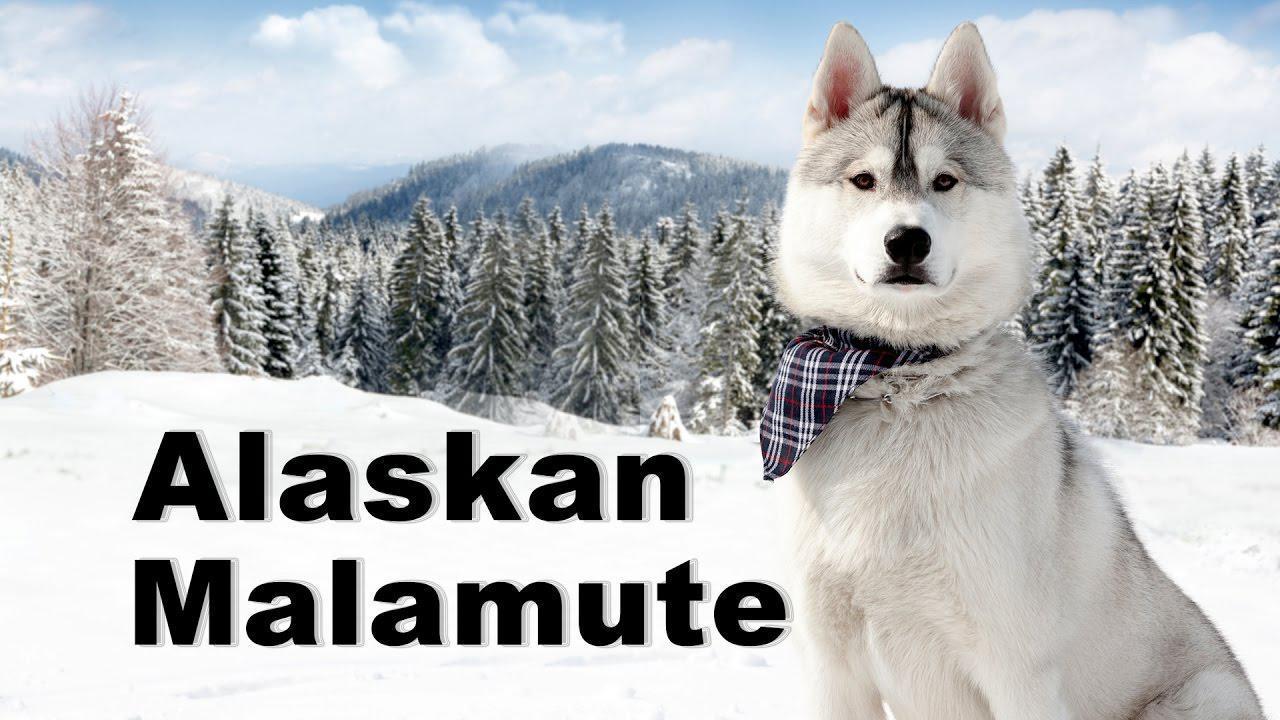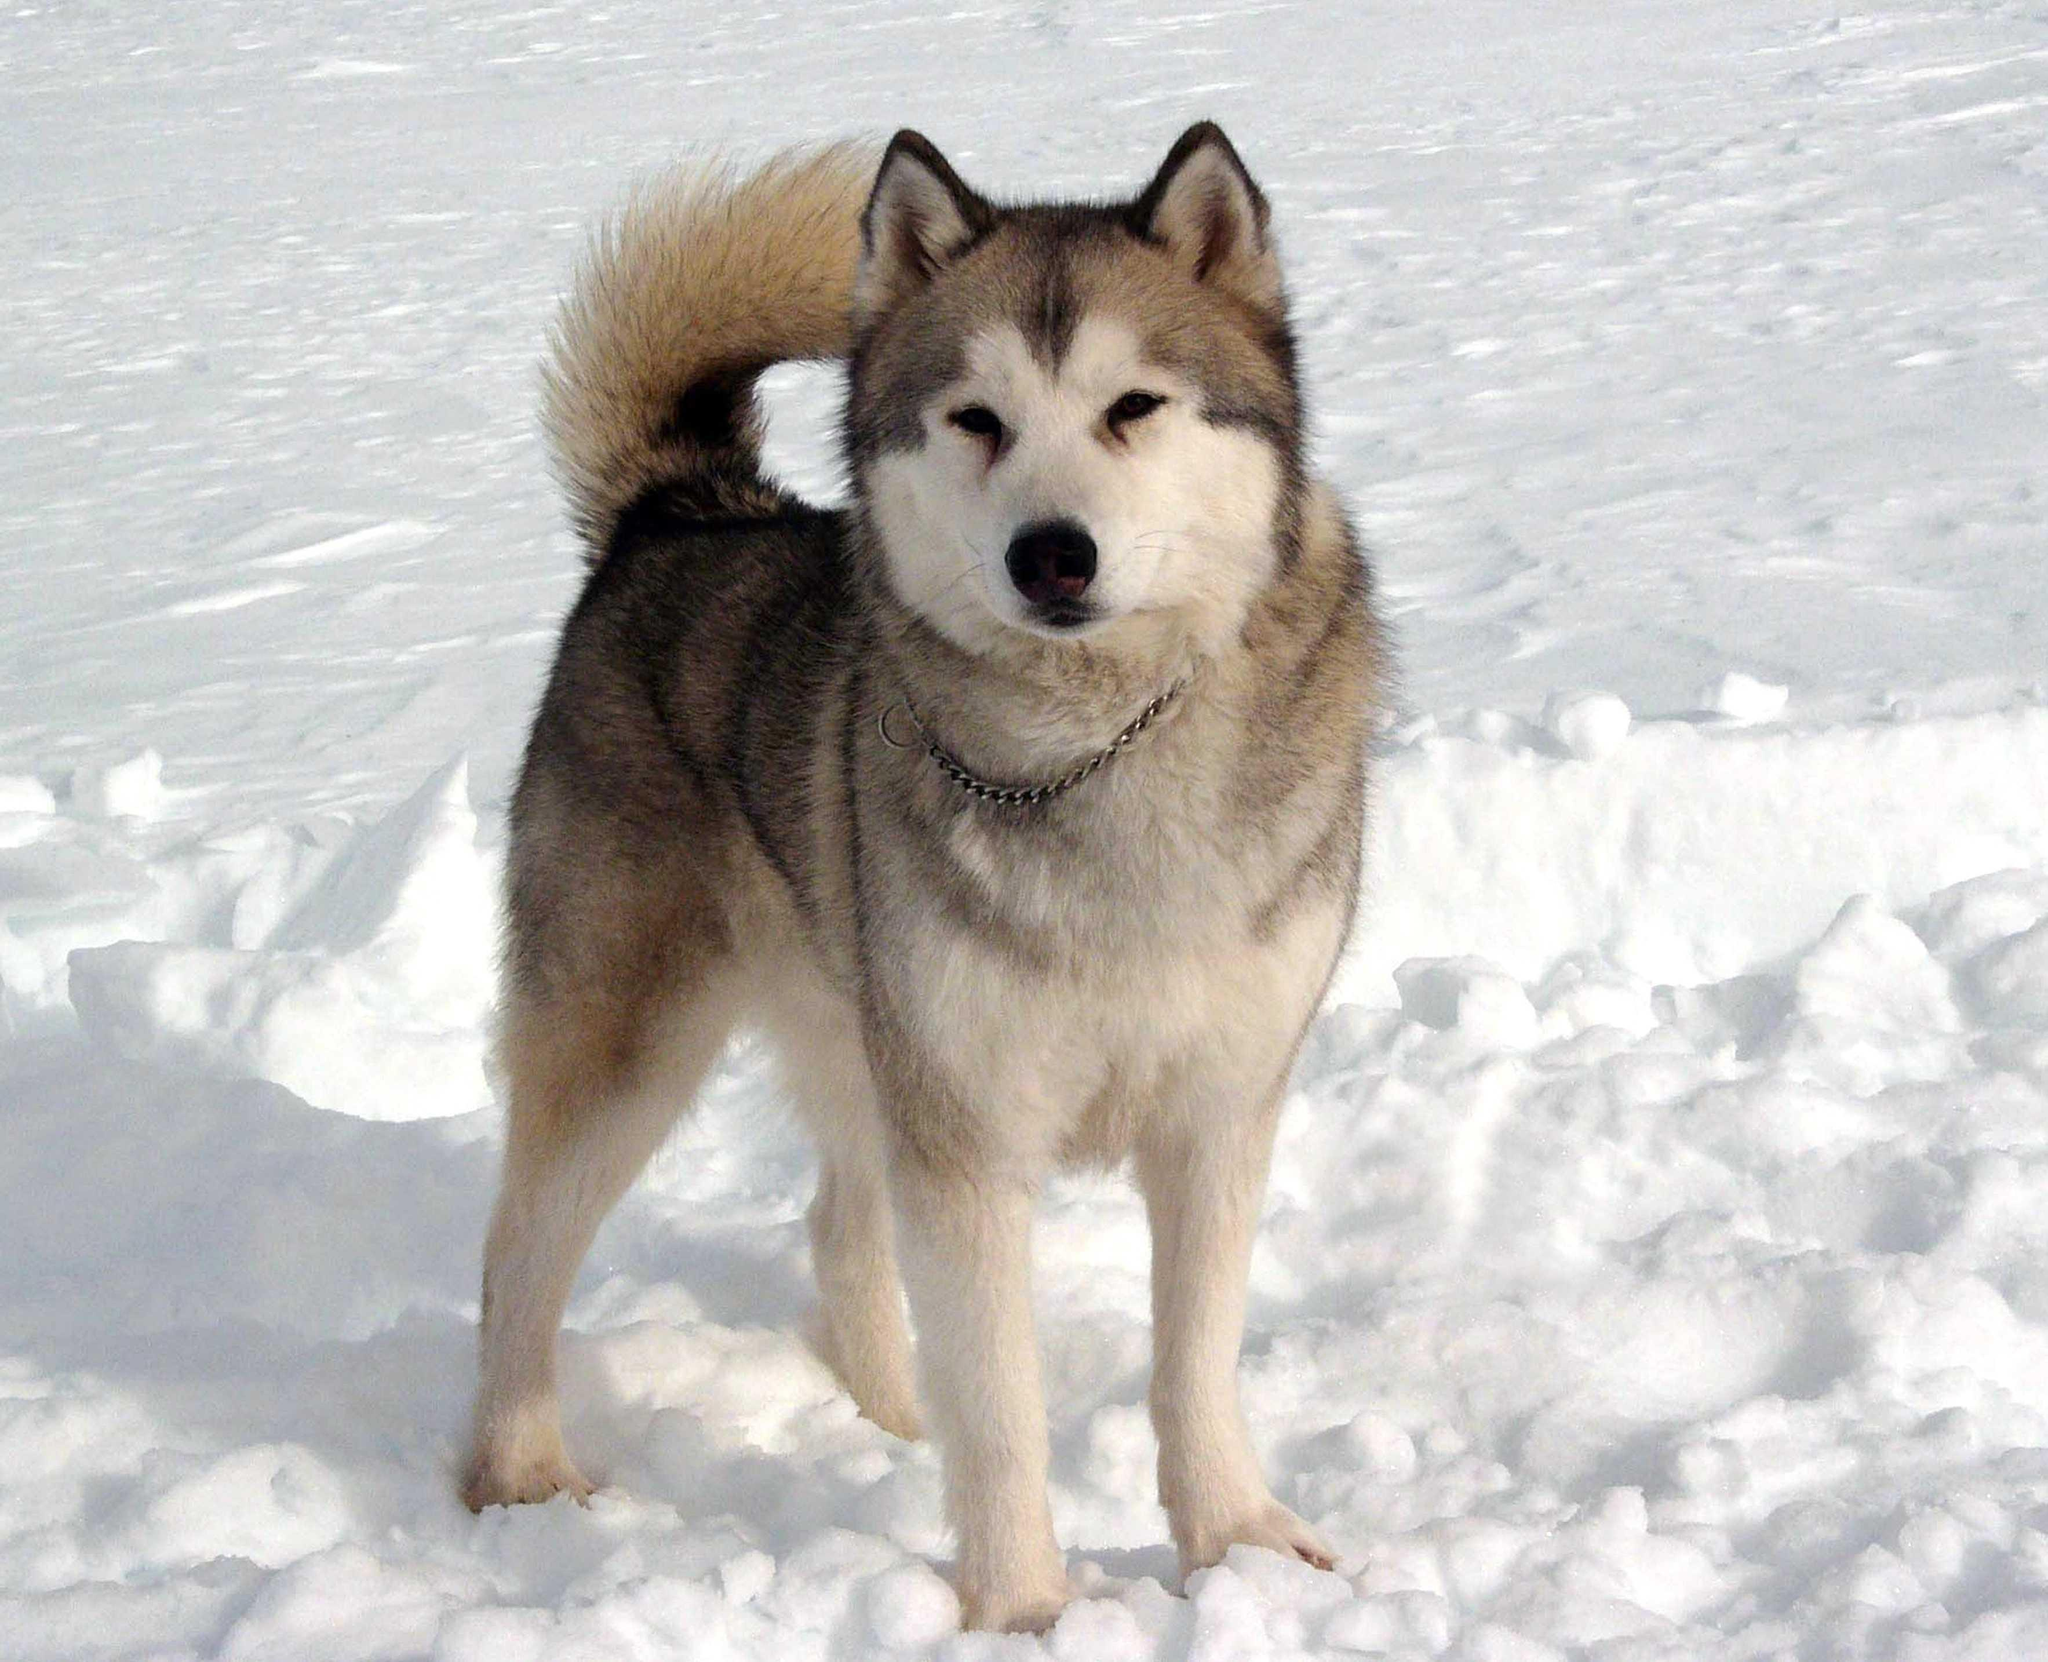The first image is the image on the left, the second image is the image on the right. For the images displayed, is the sentence "One image shows dogs hitched to a sled with a driver standing behind it and moving in a forward direction." factually correct? Answer yes or no. No. 